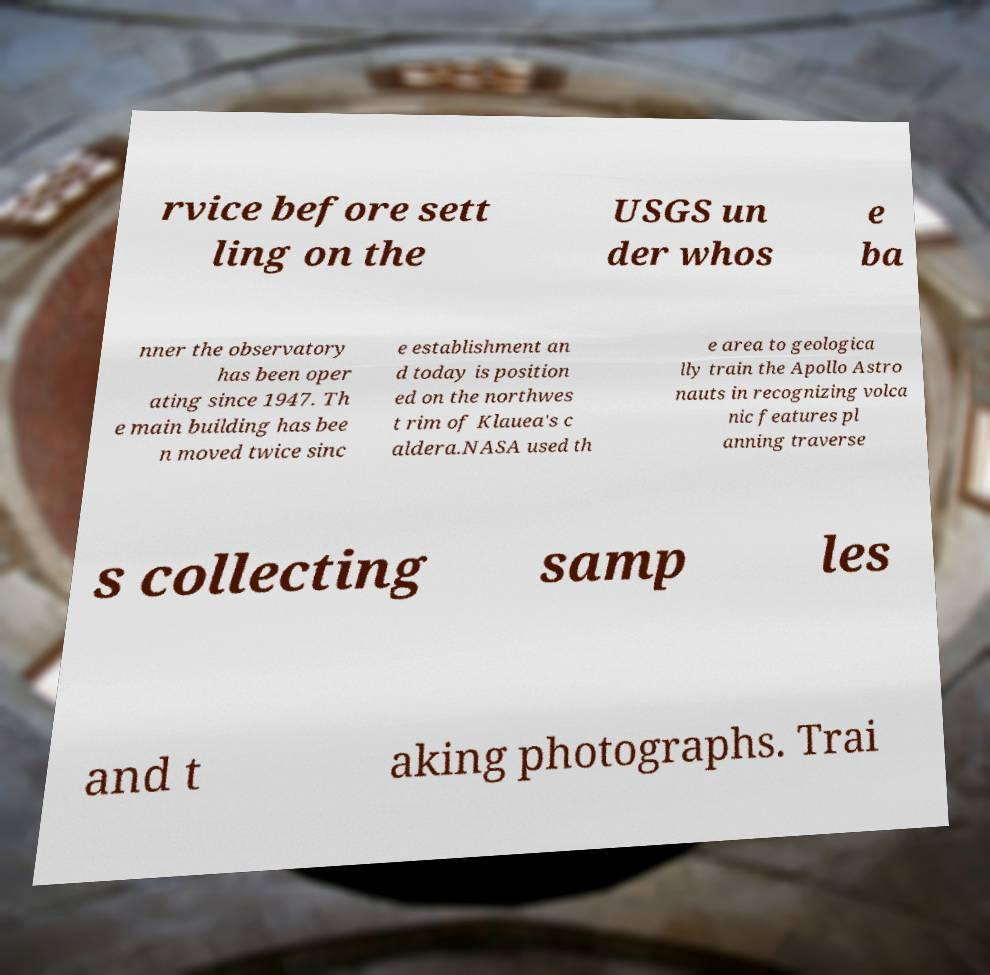For documentation purposes, I need the text within this image transcribed. Could you provide that? rvice before sett ling on the USGS un der whos e ba nner the observatory has been oper ating since 1947. Th e main building has bee n moved twice sinc e establishment an d today is position ed on the northwes t rim of Klauea's c aldera.NASA used th e area to geologica lly train the Apollo Astro nauts in recognizing volca nic features pl anning traverse s collecting samp les and t aking photographs. Trai 